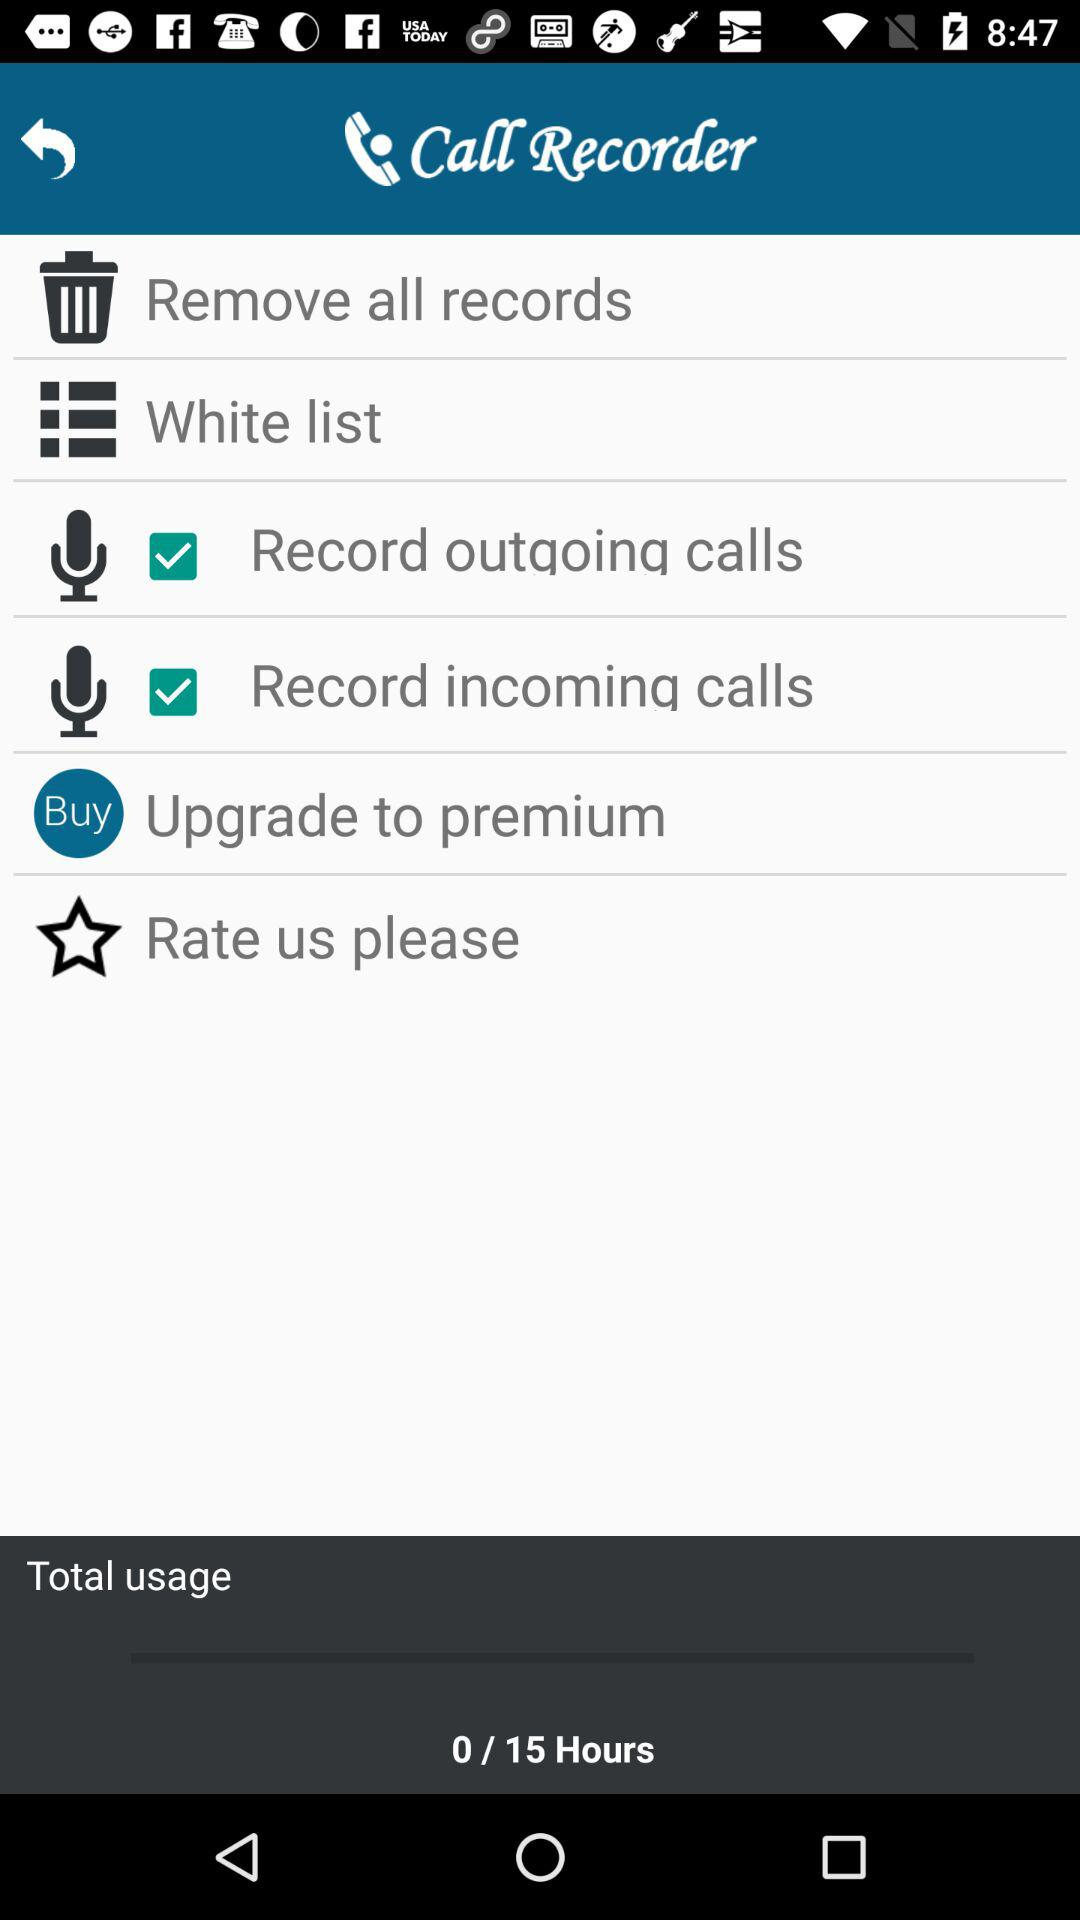How many hours of recording time are left?
Answer the question using a single word or phrase. 0/15 Hours 